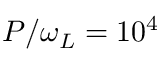Convert formula to latex. <formula><loc_0><loc_0><loc_500><loc_500>P / \omega _ { L } = 1 0 ^ { 4 }</formula> 